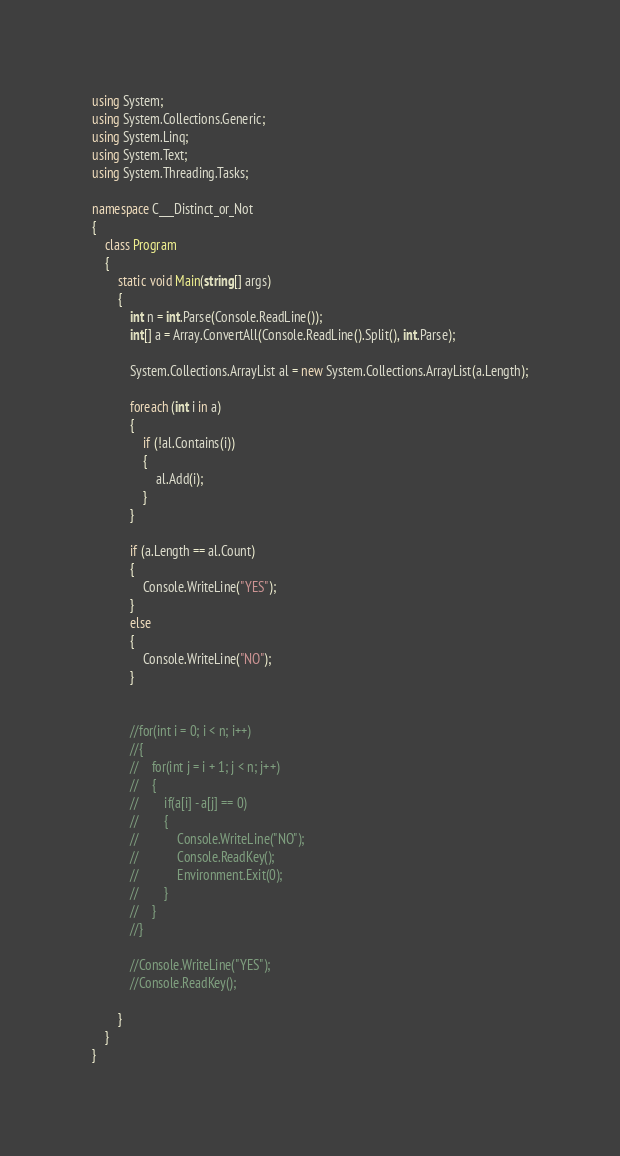Convert code to text. <code><loc_0><loc_0><loc_500><loc_500><_C#_>using System;
using System.Collections.Generic;
using System.Linq;
using System.Text;
using System.Threading.Tasks;

namespace C___Distinct_or_Not
{
    class Program
    {
        static void Main(string[] args)
        {
            int n = int.Parse(Console.ReadLine());
            int[] a = Array.ConvertAll(Console.ReadLine().Split(), int.Parse);

            System.Collections.ArrayList al = new System.Collections.ArrayList(a.Length);

            foreach (int i in a)
            {
                if (!al.Contains(i))
                {
                    al.Add(i);
                }
            }

            if (a.Length == al.Count)
            {
                Console.WriteLine("YES");
            }
            else
            {
                Console.WriteLine("NO");
            }


            //for(int i = 0; i < n; i++)
            //{
            //    for(int j = i + 1; j < n; j++)
            //    {
            //        if(a[i] - a[j] == 0)
            //        {
            //            Console.WriteLine("NO");
            //            Console.ReadKey();
            //            Environment.Exit(0);
            //        }
            //    }
            //}

            //Console.WriteLine("YES");
            //Console.ReadKey();

        }
    }
}
</code> 